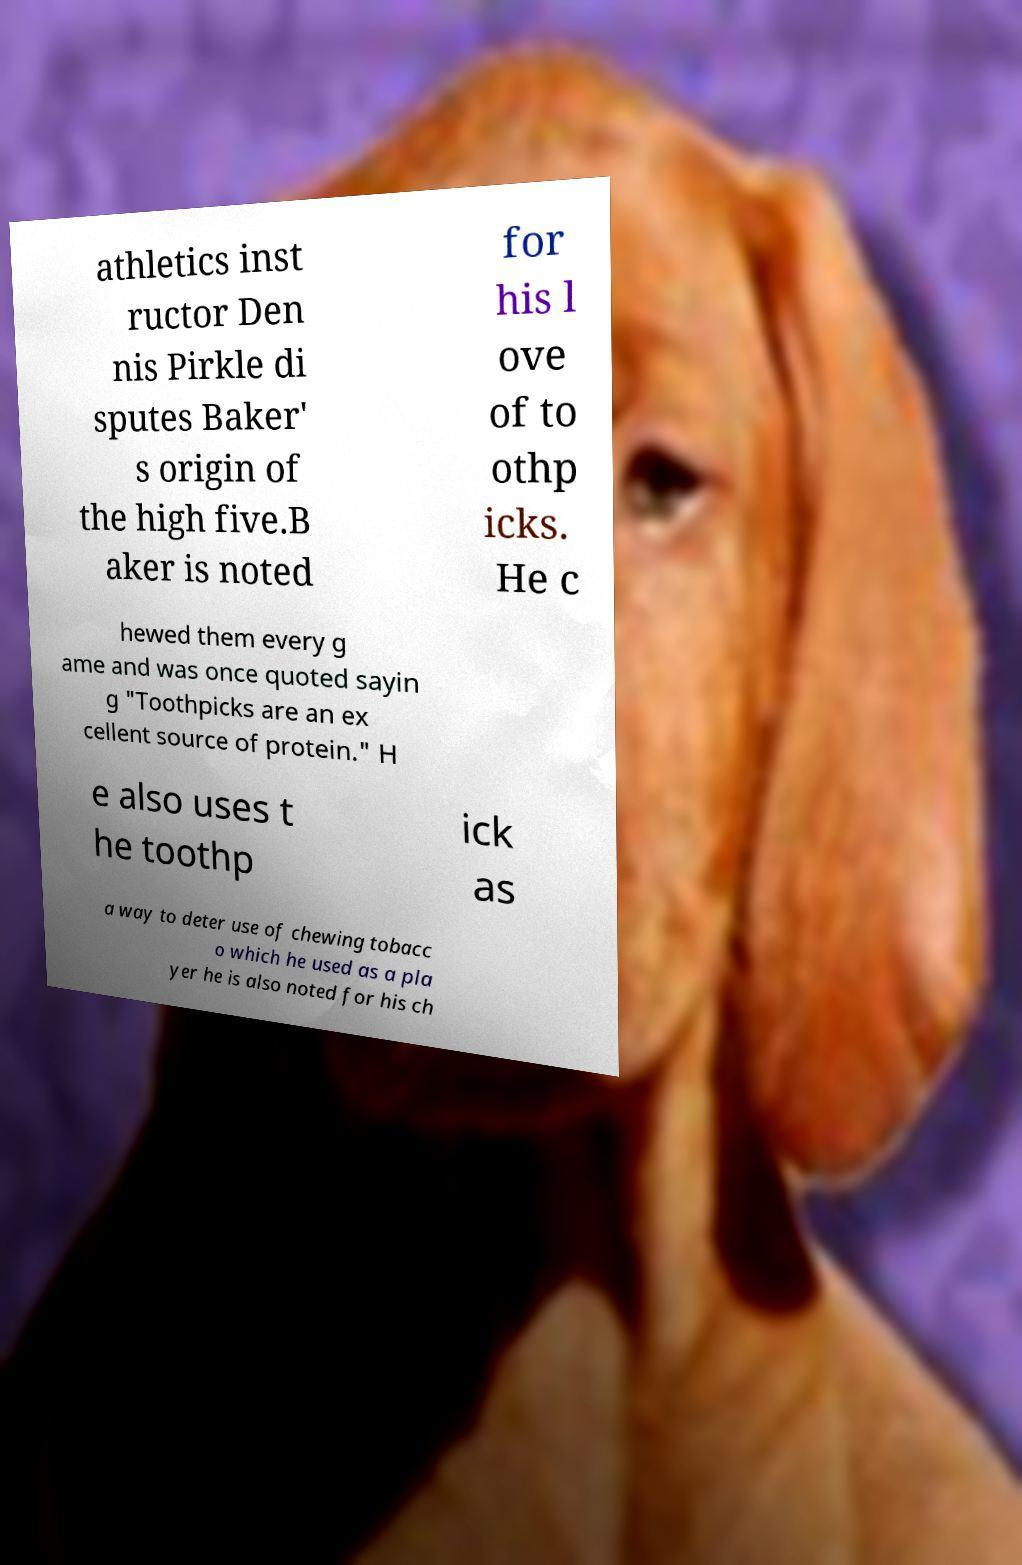What messages or text are displayed in this image? I need them in a readable, typed format. athletics inst ructor Den nis Pirkle di sputes Baker' s origin of the high five.B aker is noted for his l ove of to othp icks. He c hewed them every g ame and was once quoted sayin g "Toothpicks are an ex cellent source of protein." H e also uses t he toothp ick as a way to deter use of chewing tobacc o which he used as a pla yer he is also noted for his ch 